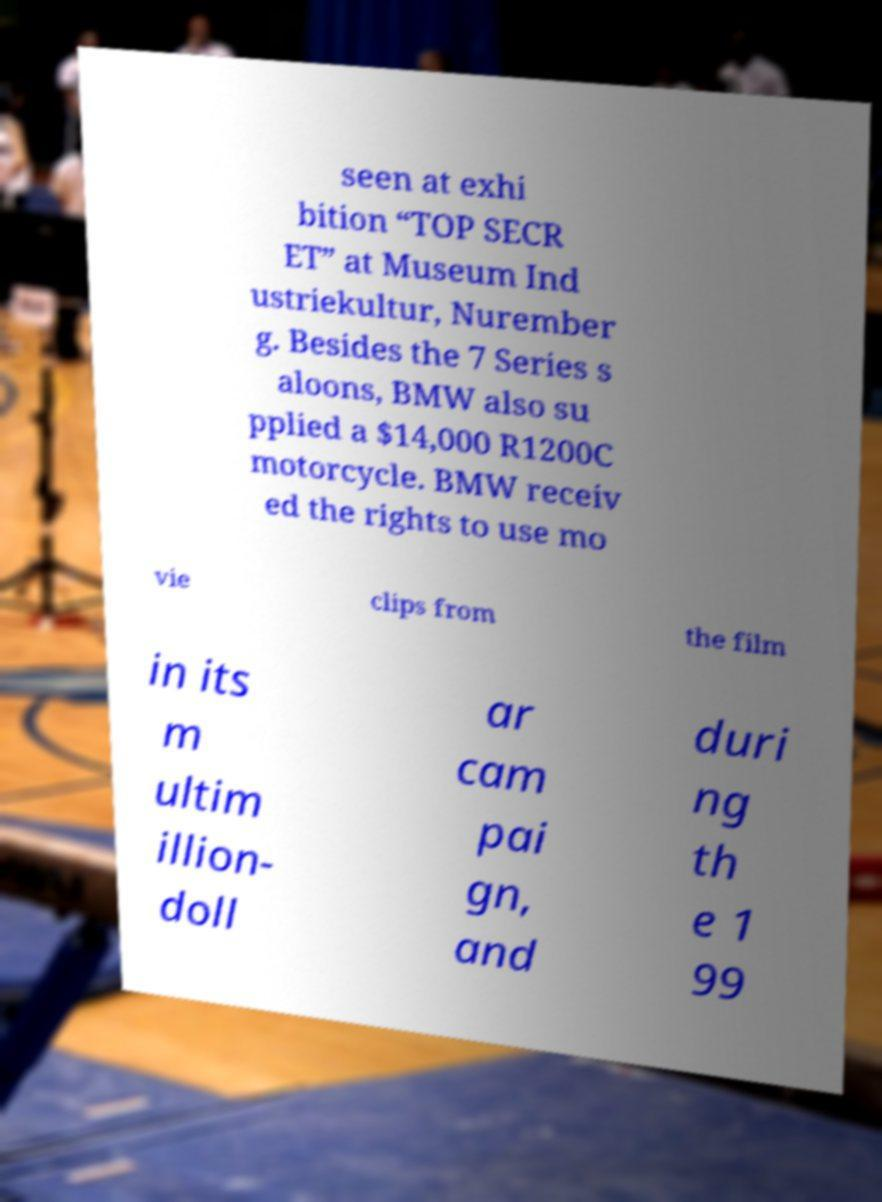Please read and relay the text visible in this image. What does it say? seen at exhi bition “TOP SECR ET” at Museum Ind ustriekultur, Nurember g. Besides the 7 Series s aloons, BMW also su pplied a $14,000 R1200C motorcycle. BMW receiv ed the rights to use mo vie clips from the film in its m ultim illion- doll ar cam pai gn, and duri ng th e 1 99 